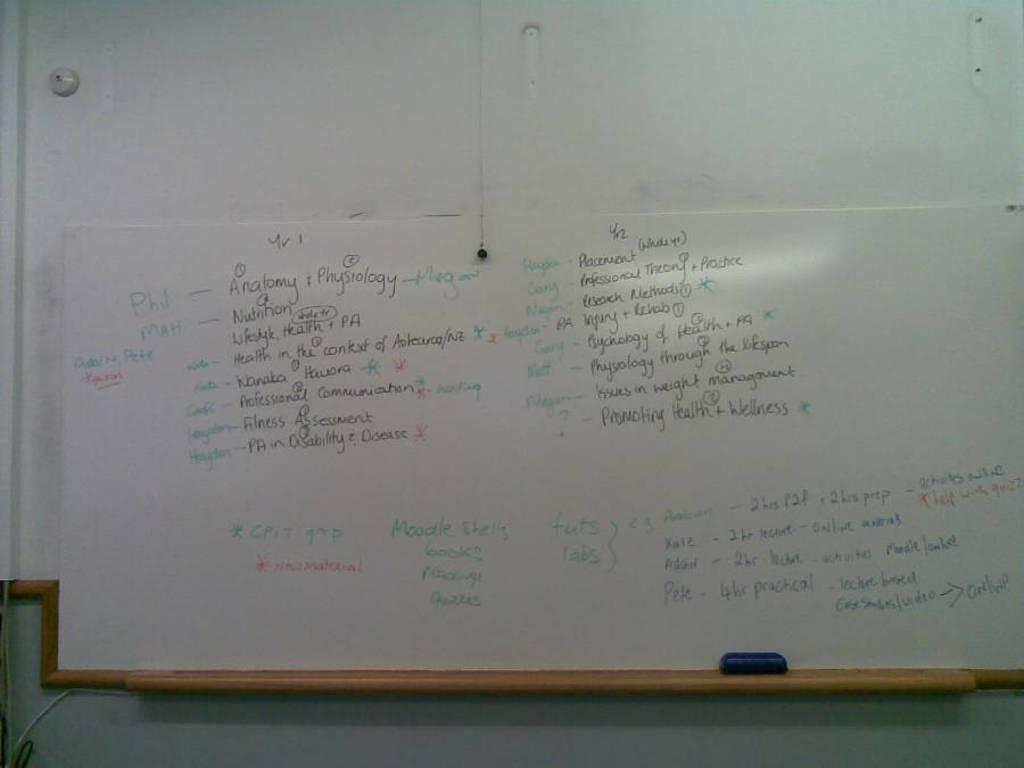<image>
Present a compact description of the photo's key features. A whiteboard is is filled with scribbles about assignment for various people like Phil, Matt and others. 